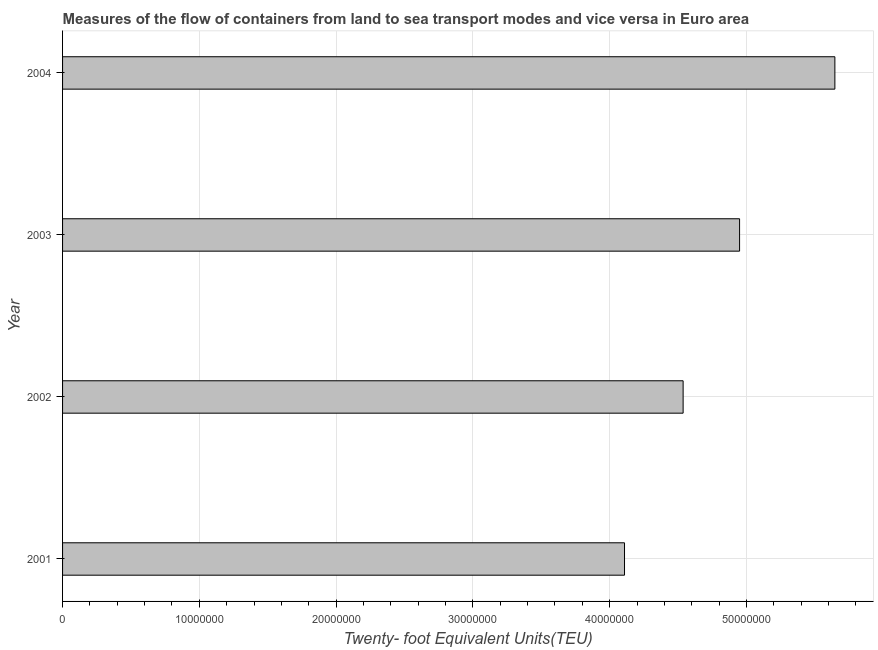Does the graph contain any zero values?
Your answer should be very brief. No. What is the title of the graph?
Offer a terse response. Measures of the flow of containers from land to sea transport modes and vice versa in Euro area. What is the label or title of the X-axis?
Your response must be concise. Twenty- foot Equivalent Units(TEU). What is the container port traffic in 2003?
Your response must be concise. 4.95e+07. Across all years, what is the maximum container port traffic?
Provide a succinct answer. 5.65e+07. Across all years, what is the minimum container port traffic?
Make the answer very short. 4.11e+07. In which year was the container port traffic maximum?
Your response must be concise. 2004. What is the sum of the container port traffic?
Your response must be concise. 1.92e+08. What is the difference between the container port traffic in 2001 and 2002?
Offer a very short reply. -4.28e+06. What is the average container port traffic per year?
Provide a succinct answer. 4.81e+07. What is the median container port traffic?
Your response must be concise. 4.74e+07. In how many years, is the container port traffic greater than 34000000 TEU?
Provide a succinct answer. 4. Do a majority of the years between 2002 and 2004 (inclusive) have container port traffic greater than 38000000 TEU?
Provide a succinct answer. Yes. What is the ratio of the container port traffic in 2001 to that in 2004?
Give a very brief answer. 0.73. Is the container port traffic in 2002 less than that in 2003?
Ensure brevity in your answer.  Yes. Is the difference between the container port traffic in 2001 and 2004 greater than the difference between any two years?
Offer a very short reply. Yes. What is the difference between the highest and the second highest container port traffic?
Keep it short and to the point. 6.97e+06. What is the difference between the highest and the lowest container port traffic?
Offer a terse response. 1.54e+07. In how many years, is the container port traffic greater than the average container port traffic taken over all years?
Offer a very short reply. 2. Are the values on the major ticks of X-axis written in scientific E-notation?
Offer a very short reply. No. What is the Twenty- foot Equivalent Units(TEU) of 2001?
Offer a terse response. 4.11e+07. What is the Twenty- foot Equivalent Units(TEU) of 2002?
Keep it short and to the point. 4.54e+07. What is the Twenty- foot Equivalent Units(TEU) in 2003?
Give a very brief answer. 4.95e+07. What is the Twenty- foot Equivalent Units(TEU) in 2004?
Keep it short and to the point. 5.65e+07. What is the difference between the Twenty- foot Equivalent Units(TEU) in 2001 and 2002?
Provide a succinct answer. -4.28e+06. What is the difference between the Twenty- foot Equivalent Units(TEU) in 2001 and 2003?
Provide a short and direct response. -8.41e+06. What is the difference between the Twenty- foot Equivalent Units(TEU) in 2001 and 2004?
Make the answer very short. -1.54e+07. What is the difference between the Twenty- foot Equivalent Units(TEU) in 2002 and 2003?
Your answer should be very brief. -4.13e+06. What is the difference between the Twenty- foot Equivalent Units(TEU) in 2002 and 2004?
Offer a terse response. -1.11e+07. What is the difference between the Twenty- foot Equivalent Units(TEU) in 2003 and 2004?
Provide a succinct answer. -6.97e+06. What is the ratio of the Twenty- foot Equivalent Units(TEU) in 2001 to that in 2002?
Your response must be concise. 0.91. What is the ratio of the Twenty- foot Equivalent Units(TEU) in 2001 to that in 2003?
Provide a short and direct response. 0.83. What is the ratio of the Twenty- foot Equivalent Units(TEU) in 2001 to that in 2004?
Provide a short and direct response. 0.73. What is the ratio of the Twenty- foot Equivalent Units(TEU) in 2002 to that in 2003?
Give a very brief answer. 0.92. What is the ratio of the Twenty- foot Equivalent Units(TEU) in 2002 to that in 2004?
Offer a very short reply. 0.8. What is the ratio of the Twenty- foot Equivalent Units(TEU) in 2003 to that in 2004?
Make the answer very short. 0.88. 